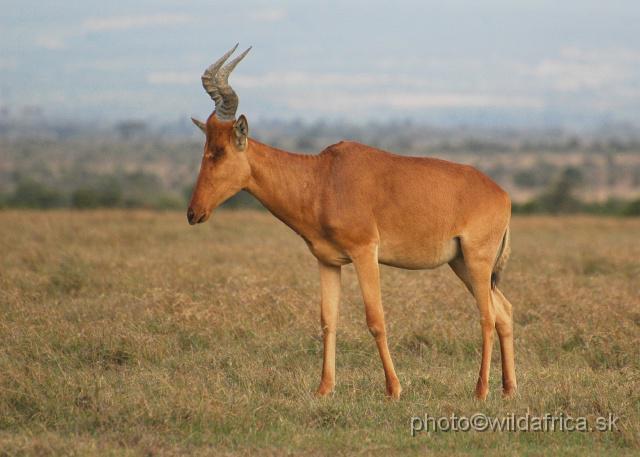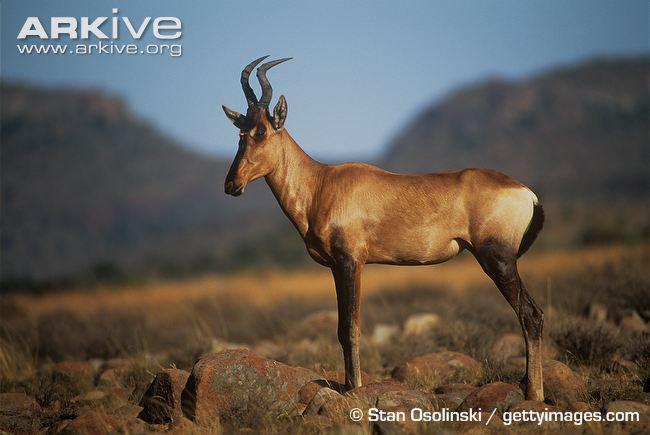The first image is the image on the left, the second image is the image on the right. Given the left and right images, does the statement "Each image contains only one horned animal, and the animal in the right image stands in profile turned leftward." hold true? Answer yes or no. Yes. The first image is the image on the left, the second image is the image on the right. Considering the images on both sides, is "Exactly one animal is pointed left." valid? Answer yes or no. No. 